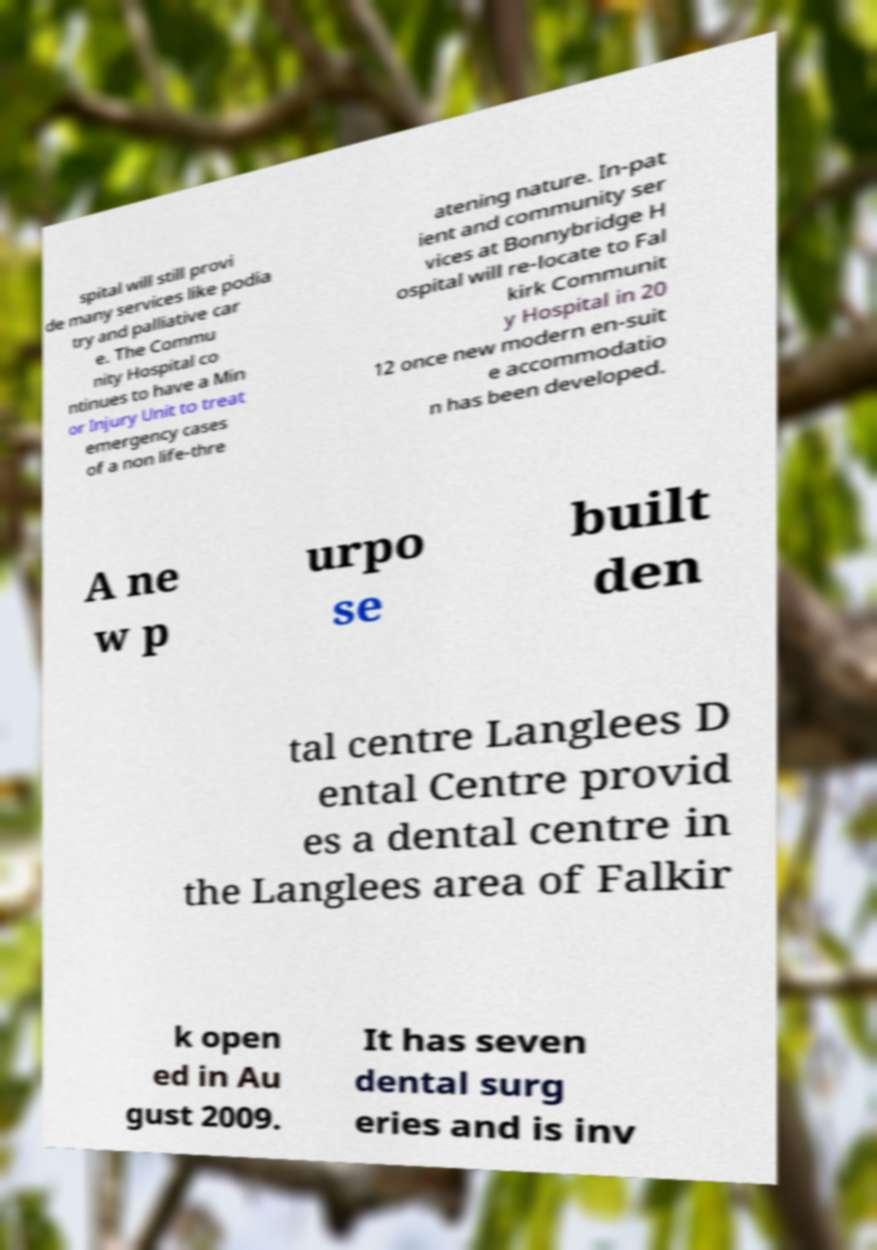I need the written content from this picture converted into text. Can you do that? spital will still provi de many services like podia try and palliative car e. The Commu nity Hospital co ntinues to have a Min or Injury Unit to treat emergency cases of a non life-thre atening nature. In-pat ient and community ser vices at Bonnybridge H ospital will re-locate to Fal kirk Communit y Hospital in 20 12 once new modern en-suit e accommodatio n has been developed. A ne w p urpo se built den tal centre Langlees D ental Centre provid es a dental centre in the Langlees area of Falkir k open ed in Au gust 2009. It has seven dental surg eries and is inv 